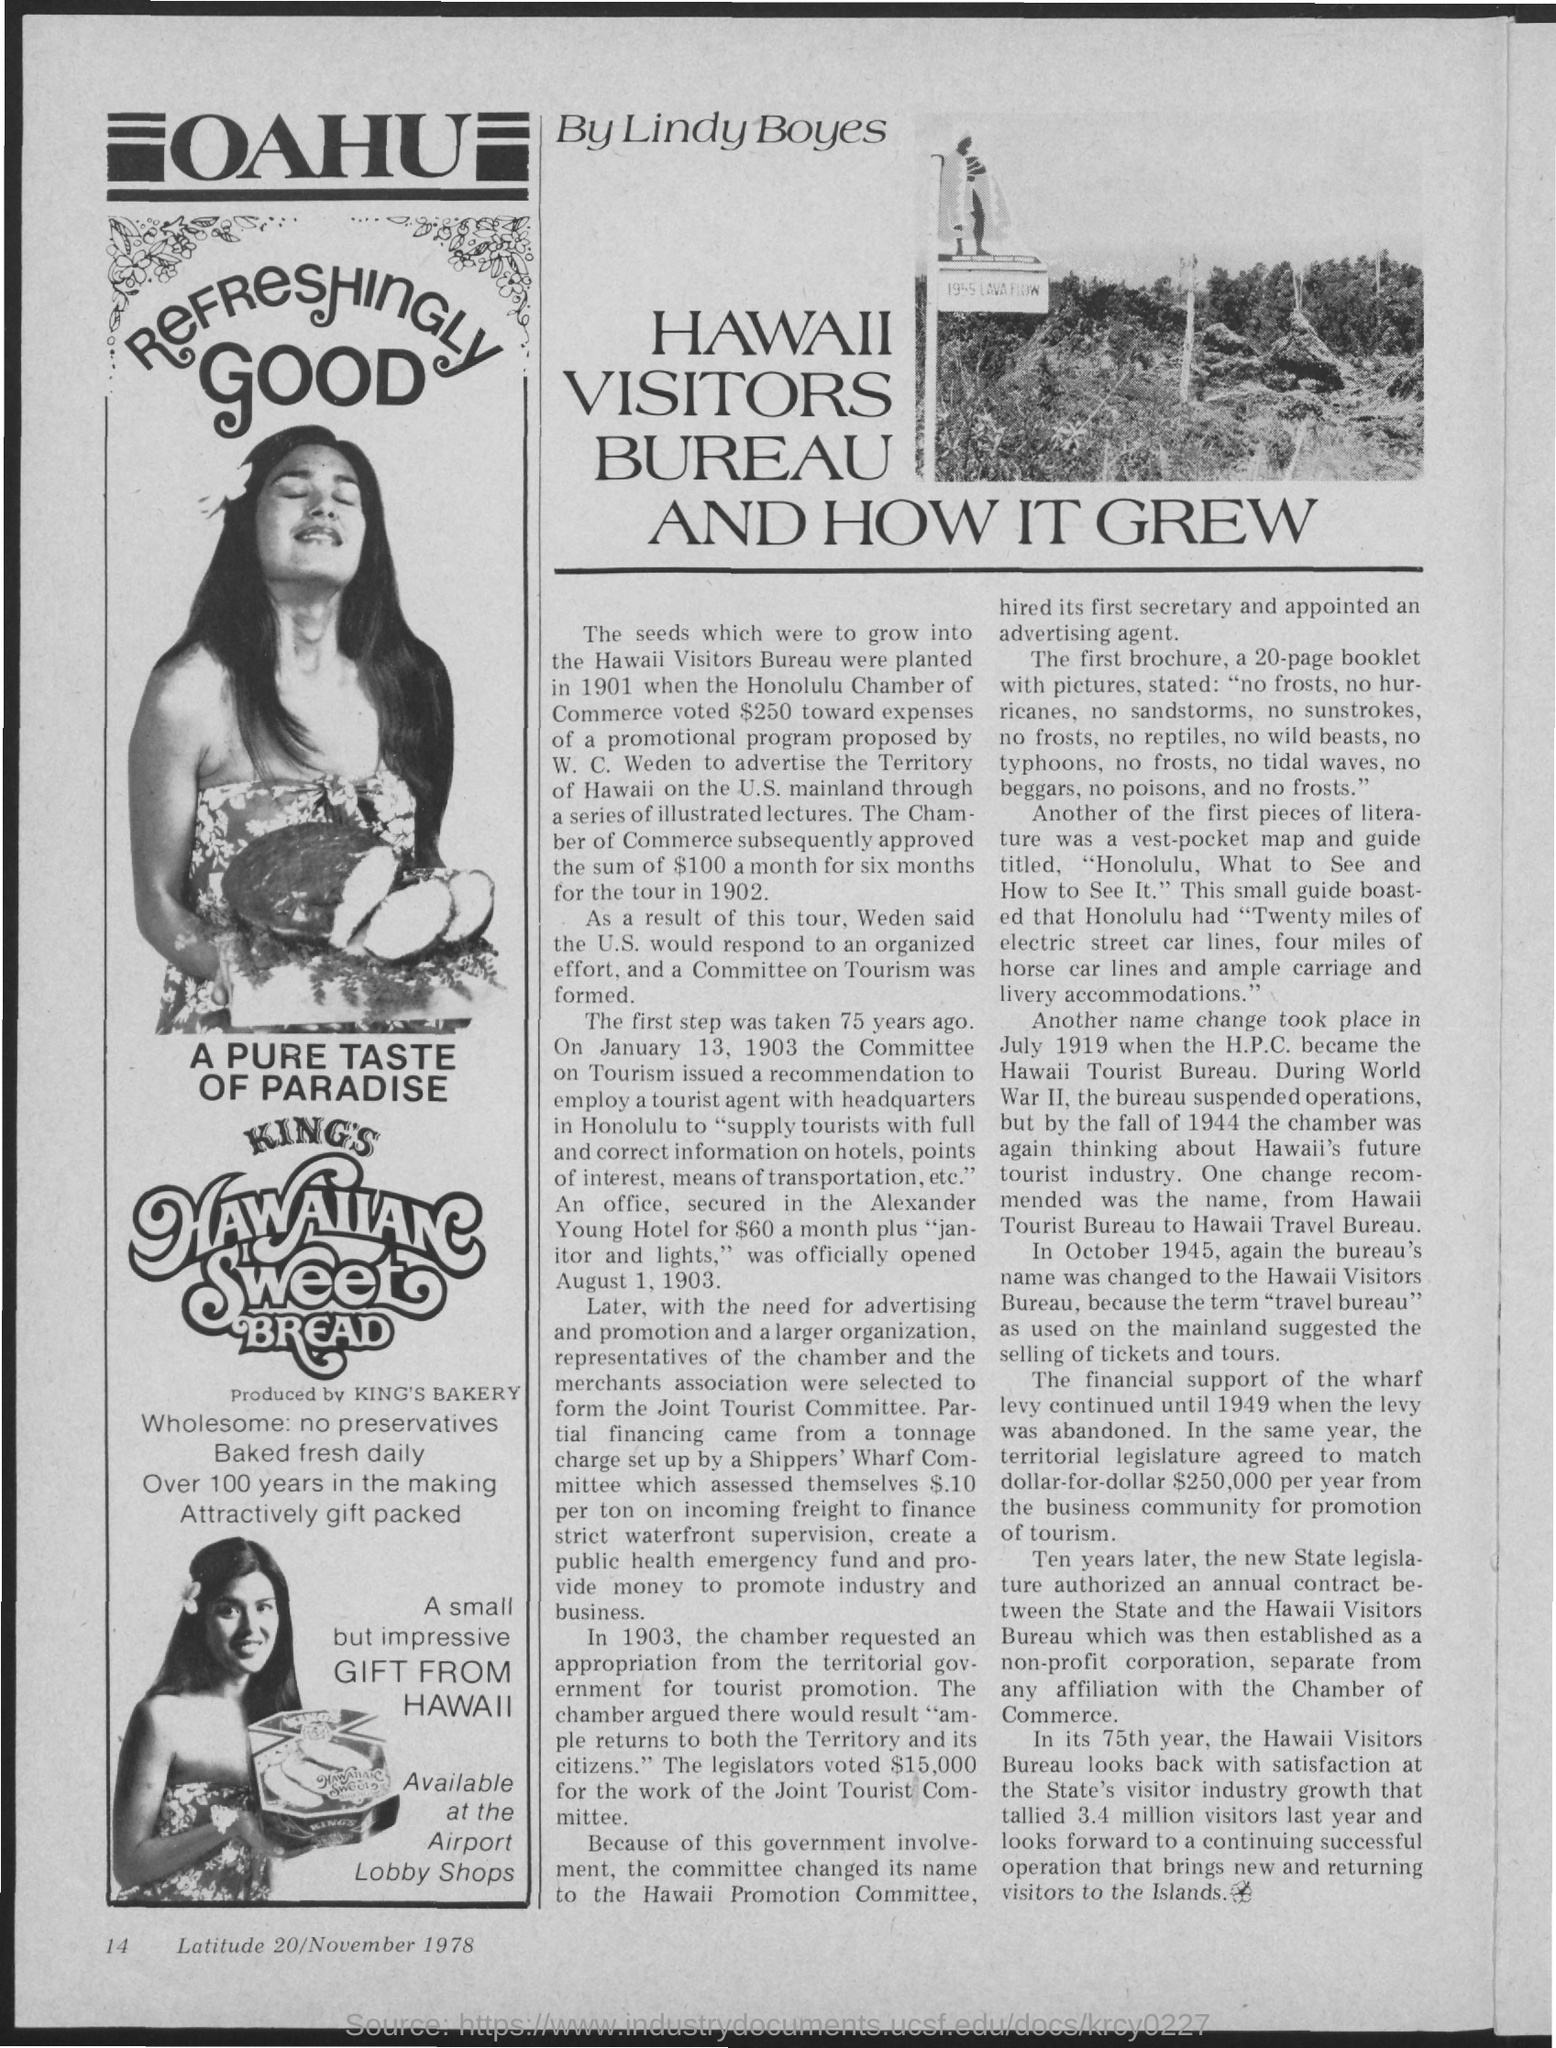Outline some significant characteristics in this image. The page number at the bottom of the page is 14. The heading to the left side of the page is 'Oahu'.  The date at the bottom of the page is 20 November 1978. King's Bakery produces Hawaiian sweet bread. The author of this article is Lindy Boyes. 